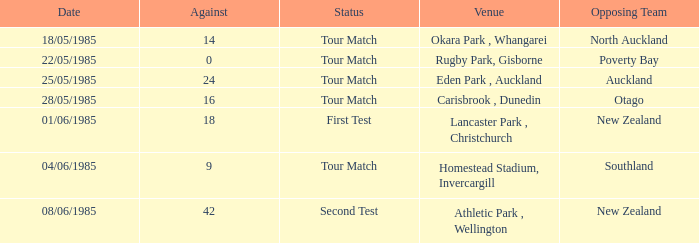What date was the opposing team Poverty Bay? 22/05/1985. 